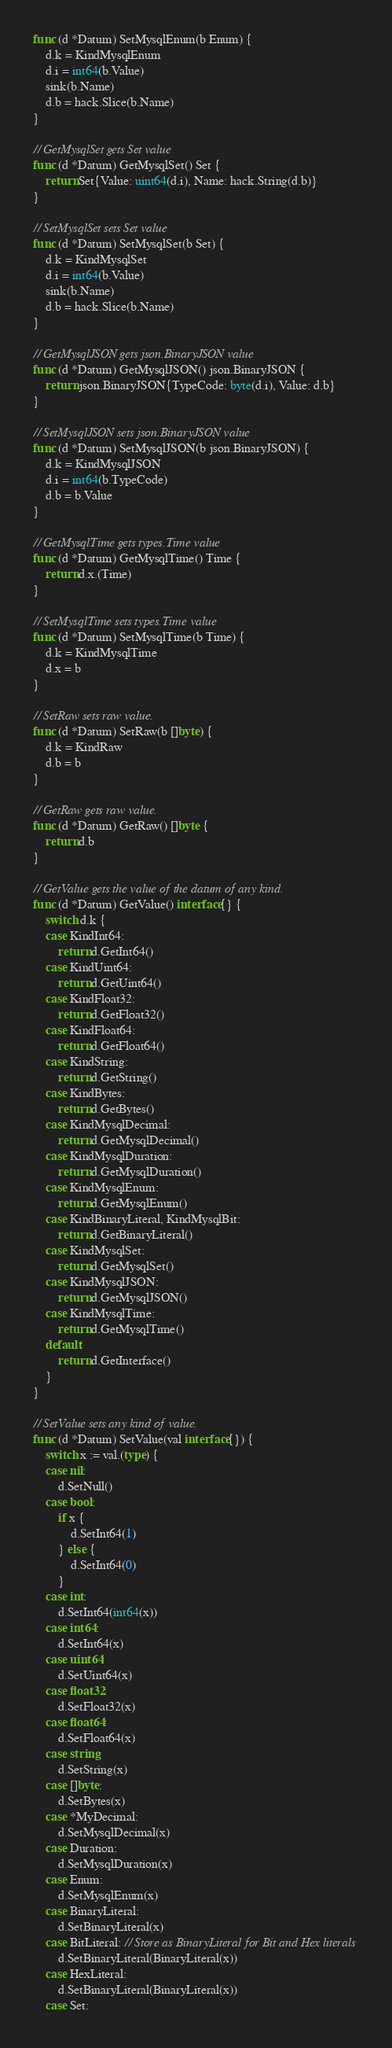Convert code to text. <code><loc_0><loc_0><loc_500><loc_500><_Go_>func (d *Datum) SetMysqlEnum(b Enum) {
	d.k = KindMysqlEnum
	d.i = int64(b.Value)
	sink(b.Name)
	d.b = hack.Slice(b.Name)
}

// GetMysqlSet gets Set value
func (d *Datum) GetMysqlSet() Set {
	return Set{Value: uint64(d.i), Name: hack.String(d.b)}
}

// SetMysqlSet sets Set value
func (d *Datum) SetMysqlSet(b Set) {
	d.k = KindMysqlSet
	d.i = int64(b.Value)
	sink(b.Name)
	d.b = hack.Slice(b.Name)
}

// GetMysqlJSON gets json.BinaryJSON value
func (d *Datum) GetMysqlJSON() json.BinaryJSON {
	return json.BinaryJSON{TypeCode: byte(d.i), Value: d.b}
}

// SetMysqlJSON sets json.BinaryJSON value
func (d *Datum) SetMysqlJSON(b json.BinaryJSON) {
	d.k = KindMysqlJSON
	d.i = int64(b.TypeCode)
	d.b = b.Value
}

// GetMysqlTime gets types.Time value
func (d *Datum) GetMysqlTime() Time {
	return d.x.(Time)
}

// SetMysqlTime sets types.Time value
func (d *Datum) SetMysqlTime(b Time) {
	d.k = KindMysqlTime
	d.x = b
}

// SetRaw sets raw value.
func (d *Datum) SetRaw(b []byte) {
	d.k = KindRaw
	d.b = b
}

// GetRaw gets raw value.
func (d *Datum) GetRaw() []byte {
	return d.b
}

// GetValue gets the value of the datum of any kind.
func (d *Datum) GetValue() interface{} {
	switch d.k {
	case KindInt64:
		return d.GetInt64()
	case KindUint64:
		return d.GetUint64()
	case KindFloat32:
		return d.GetFloat32()
	case KindFloat64:
		return d.GetFloat64()
	case KindString:
		return d.GetString()
	case KindBytes:
		return d.GetBytes()
	case KindMysqlDecimal:
		return d.GetMysqlDecimal()
	case KindMysqlDuration:
		return d.GetMysqlDuration()
	case KindMysqlEnum:
		return d.GetMysqlEnum()
	case KindBinaryLiteral, KindMysqlBit:
		return d.GetBinaryLiteral()
	case KindMysqlSet:
		return d.GetMysqlSet()
	case KindMysqlJSON:
		return d.GetMysqlJSON()
	case KindMysqlTime:
		return d.GetMysqlTime()
	default:
		return d.GetInterface()
	}
}

// SetValue sets any kind of value.
func (d *Datum) SetValue(val interface{}) {
	switch x := val.(type) {
	case nil:
		d.SetNull()
	case bool:
		if x {
			d.SetInt64(1)
		} else {
			d.SetInt64(0)
		}
	case int:
		d.SetInt64(int64(x))
	case int64:
		d.SetInt64(x)
	case uint64:
		d.SetUint64(x)
	case float32:
		d.SetFloat32(x)
	case float64:
		d.SetFloat64(x)
	case string:
		d.SetString(x)
	case []byte:
		d.SetBytes(x)
	case *MyDecimal:
		d.SetMysqlDecimal(x)
	case Duration:
		d.SetMysqlDuration(x)
	case Enum:
		d.SetMysqlEnum(x)
	case BinaryLiteral:
		d.SetBinaryLiteral(x)
	case BitLiteral: // Store as BinaryLiteral for Bit and Hex literals
		d.SetBinaryLiteral(BinaryLiteral(x))
	case HexLiteral:
		d.SetBinaryLiteral(BinaryLiteral(x))
	case Set:</code> 